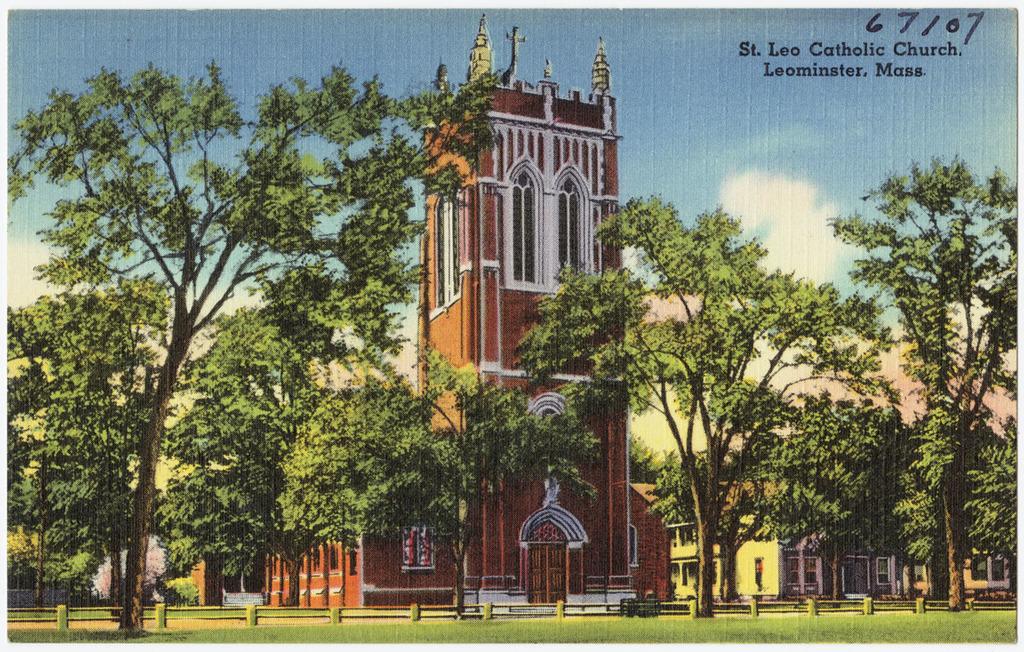In which city is the church located?
Your response must be concise. Leominster. What is the name of the church?
Offer a very short reply. St. leo catholic church. 